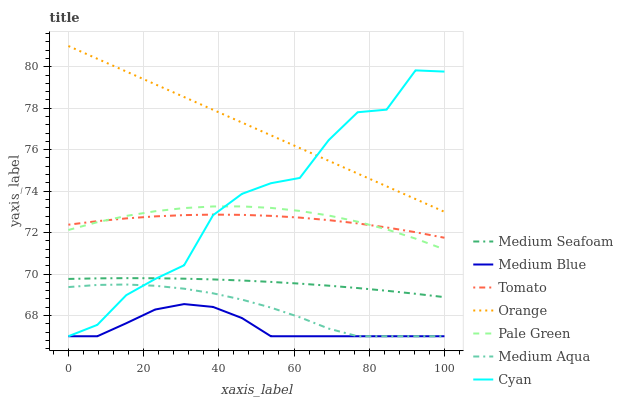Does Medium Blue have the minimum area under the curve?
Answer yes or no. Yes. Does Orange have the maximum area under the curve?
Answer yes or no. Yes. Does Pale Green have the minimum area under the curve?
Answer yes or no. No. Does Pale Green have the maximum area under the curve?
Answer yes or no. No. Is Orange the smoothest?
Answer yes or no. Yes. Is Cyan the roughest?
Answer yes or no. Yes. Is Medium Blue the smoothest?
Answer yes or no. No. Is Medium Blue the roughest?
Answer yes or no. No. Does Pale Green have the lowest value?
Answer yes or no. No. Does Orange have the highest value?
Answer yes or no. Yes. Does Pale Green have the highest value?
Answer yes or no. No. Is Medium Seafoam less than Tomato?
Answer yes or no. Yes. Is Orange greater than Medium Blue?
Answer yes or no. Yes. Does Medium Aqua intersect Cyan?
Answer yes or no. Yes. Is Medium Aqua less than Cyan?
Answer yes or no. No. Is Medium Aqua greater than Cyan?
Answer yes or no. No. Does Medium Seafoam intersect Tomato?
Answer yes or no. No. 